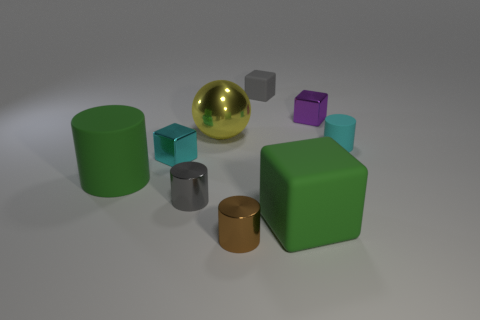There is a tiny block in front of the cyan object that is behind the cyan shiny thing; are there any tiny cubes that are behind it?
Offer a terse response. Yes. What number of metallic objects are small cylinders or cyan objects?
Ensure brevity in your answer.  3. Is the color of the sphere the same as the big matte cylinder?
Your response must be concise. No. What number of large yellow objects are to the right of the tiny rubber cube?
Keep it short and to the point. 0. What number of tiny objects are both left of the tiny cyan cylinder and behind the cyan cube?
Provide a short and direct response. 2. What shape is the large object that is made of the same material as the big cylinder?
Offer a terse response. Cube. There is a cube that is in front of the small gray cylinder; is it the same size as the gray thing that is in front of the small purple metal cube?
Offer a very short reply. No. There is a matte block behind the green rubber block; what is its color?
Offer a terse response. Gray. There is a small cylinder that is behind the block left of the gray block; what is it made of?
Offer a very short reply. Rubber. What is the shape of the tiny gray matte object?
Make the answer very short. Cube. 